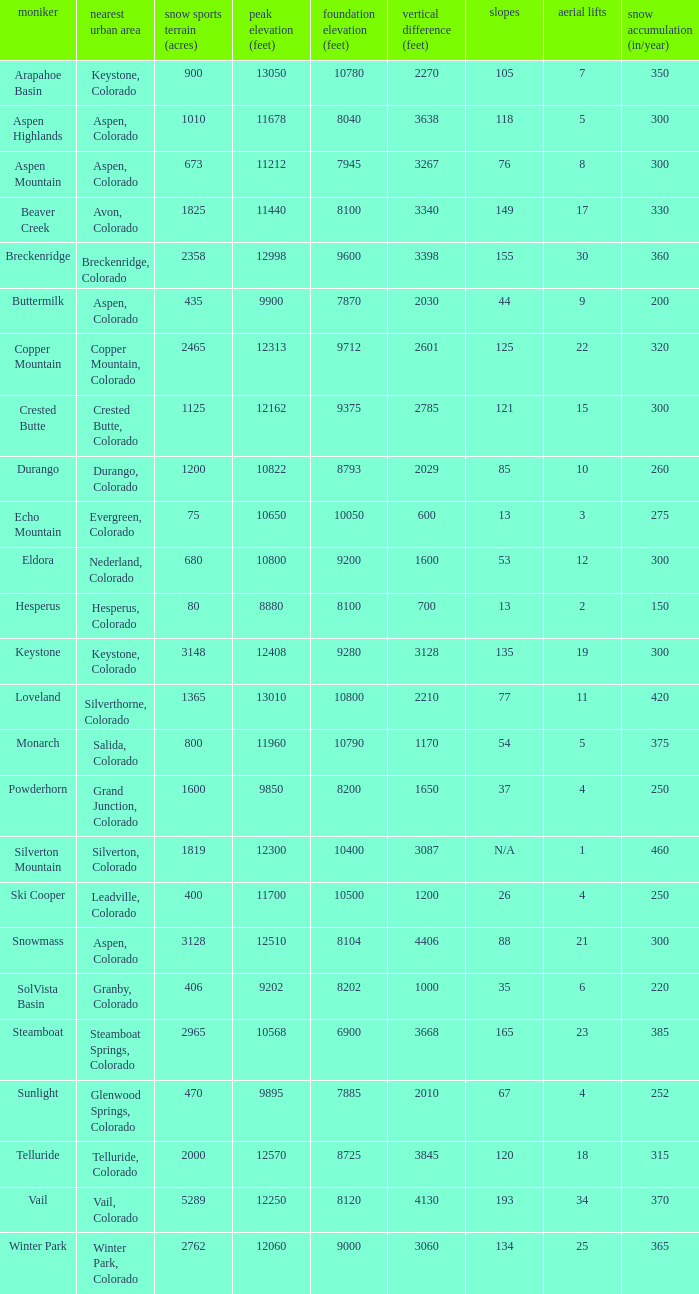What is the snowfall for ski resort Snowmass? 300.0. Parse the full table. {'header': ['moniker', 'nearest urban area', 'snow sports terrain (acres)', 'peak elevation (feet)', 'foundation elevation (feet)', 'vertical difference (feet)', 'slopes', 'aerial lifts', 'snow accumulation (in/year)'], 'rows': [['Arapahoe Basin', 'Keystone, Colorado', '900', '13050', '10780', '2270', '105', '7', '350'], ['Aspen Highlands', 'Aspen, Colorado', '1010', '11678', '8040', '3638', '118', '5', '300'], ['Aspen Mountain', 'Aspen, Colorado', '673', '11212', '7945', '3267', '76', '8', '300'], ['Beaver Creek', 'Avon, Colorado', '1825', '11440', '8100', '3340', '149', '17', '330'], ['Breckenridge', 'Breckenridge, Colorado', '2358', '12998', '9600', '3398', '155', '30', '360'], ['Buttermilk', 'Aspen, Colorado', '435', '9900', '7870', '2030', '44', '9', '200'], ['Copper Mountain', 'Copper Mountain, Colorado', '2465', '12313', '9712', '2601', '125', '22', '320'], ['Crested Butte', 'Crested Butte, Colorado', '1125', '12162', '9375', '2785', '121', '15', '300'], ['Durango', 'Durango, Colorado', '1200', '10822', '8793', '2029', '85', '10', '260'], ['Echo Mountain', 'Evergreen, Colorado', '75', '10650', '10050', '600', '13', '3', '275'], ['Eldora', 'Nederland, Colorado', '680', '10800', '9200', '1600', '53', '12', '300'], ['Hesperus', 'Hesperus, Colorado', '80', '8880', '8100', '700', '13', '2', '150'], ['Keystone', 'Keystone, Colorado', '3148', '12408', '9280', '3128', '135', '19', '300'], ['Loveland', 'Silverthorne, Colorado', '1365', '13010', '10800', '2210', '77', '11', '420'], ['Monarch', 'Salida, Colorado', '800', '11960', '10790', '1170', '54', '5', '375'], ['Powderhorn', 'Grand Junction, Colorado', '1600', '9850', '8200', '1650', '37', '4', '250'], ['Silverton Mountain', 'Silverton, Colorado', '1819', '12300', '10400', '3087', 'N/A', '1', '460'], ['Ski Cooper', 'Leadville, Colorado', '400', '11700', '10500', '1200', '26', '4', '250'], ['Snowmass', 'Aspen, Colorado', '3128', '12510', '8104', '4406', '88', '21', '300'], ['SolVista Basin', 'Granby, Colorado', '406', '9202', '8202', '1000', '35', '6', '220'], ['Steamboat', 'Steamboat Springs, Colorado', '2965', '10568', '6900', '3668', '165', '23', '385'], ['Sunlight', 'Glenwood Springs, Colorado', '470', '9895', '7885', '2010', '67', '4', '252'], ['Telluride', 'Telluride, Colorado', '2000', '12570', '8725', '3845', '120', '18', '315'], ['Vail', 'Vail, Colorado', '5289', '12250', '8120', '4130', '193', '34', '370'], ['Winter Park', 'Winter Park, Colorado', '2762', '12060', '9000', '3060', '134', '25', '365']]} 